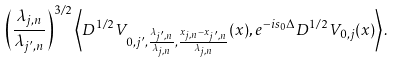<formula> <loc_0><loc_0><loc_500><loc_500>\left ( \frac { \lambda _ { j , n } } { \lambda _ { j ^ { \prime } , n } } \right ) ^ { 3 / 2 } \left < D ^ { 1 / 2 } V _ { 0 , j ^ { \prime } , \frac { \lambda _ { j ^ { \prime } , n } } { \lambda _ { j , n } } , \frac { x _ { j , n } - x _ { j ^ { \prime } , n } } { \lambda _ { j , n } } } ( x ) , e ^ { - i s _ { 0 } \Delta } D ^ { 1 / 2 } V _ { 0 , j } ( x ) \right > .</formula> 